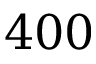<formula> <loc_0><loc_0><loc_500><loc_500>4 0 0</formula> 